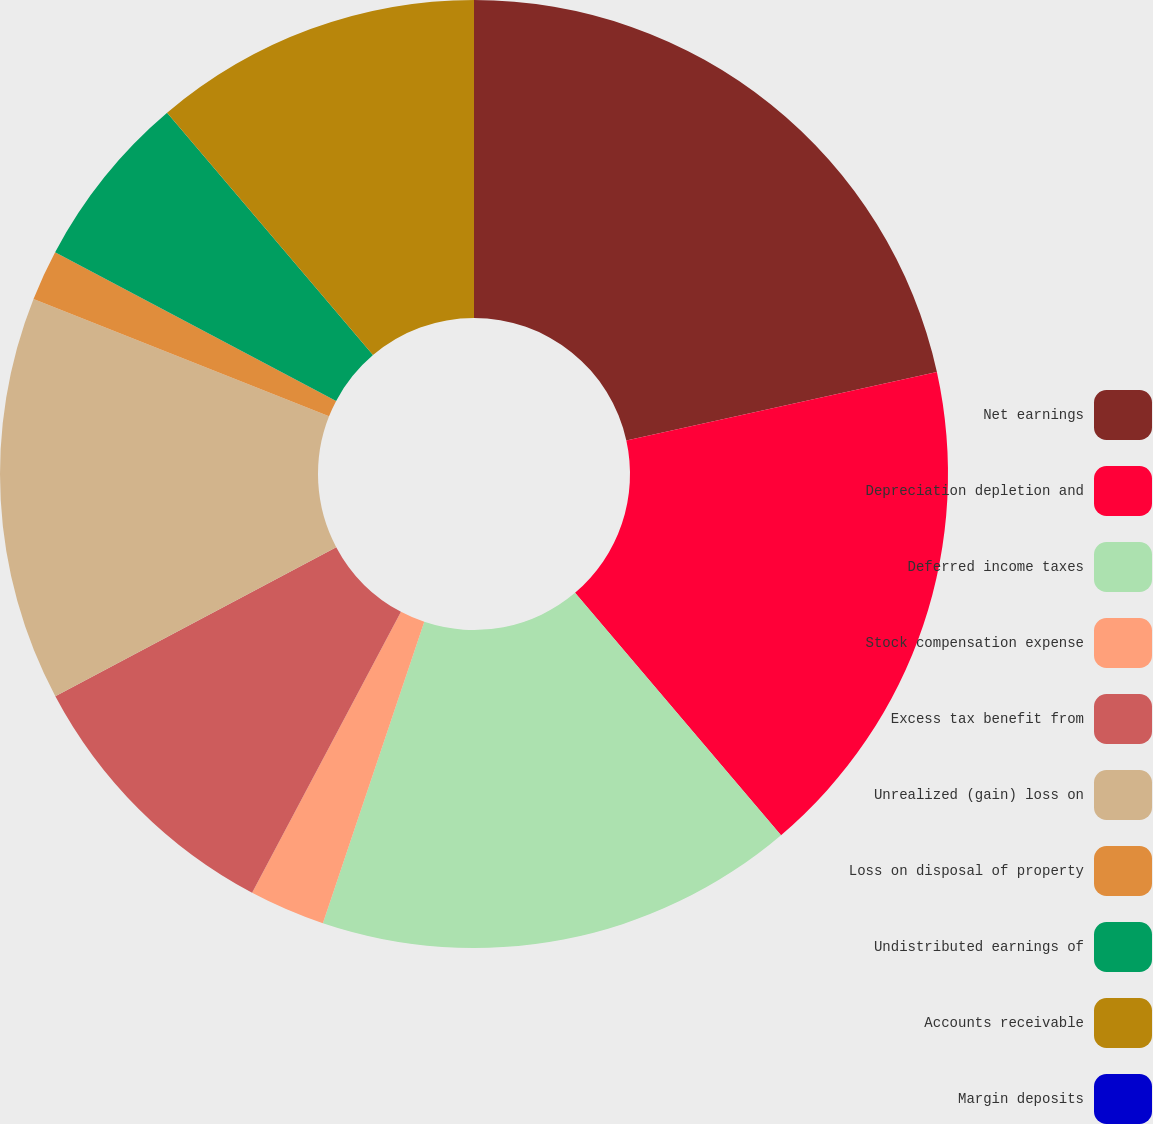Convert chart to OTSL. <chart><loc_0><loc_0><loc_500><loc_500><pie_chart><fcel>Net earnings<fcel>Depreciation depletion and<fcel>Deferred income taxes<fcel>Stock compensation expense<fcel>Excess tax benefit from<fcel>Unrealized (gain) loss on<fcel>Loss on disposal of property<fcel>Undistributed earnings of<fcel>Accounts receivable<fcel>Margin deposits<nl><fcel>21.55%<fcel>17.24%<fcel>16.38%<fcel>2.59%<fcel>9.48%<fcel>13.79%<fcel>1.73%<fcel>6.04%<fcel>11.21%<fcel>0.0%<nl></chart> 